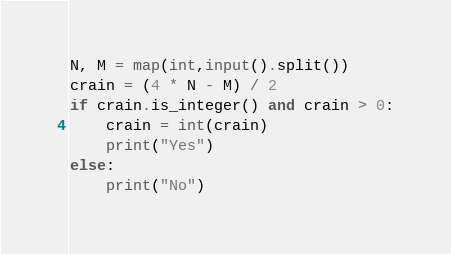<code> <loc_0><loc_0><loc_500><loc_500><_Python_>N, M = map(int,input().split())
crain = (4 * N - M) / 2
if crain.is_integer() and crain > 0:
    crain = int(crain)
    print("Yes")
else:
    print("No")
</code> 